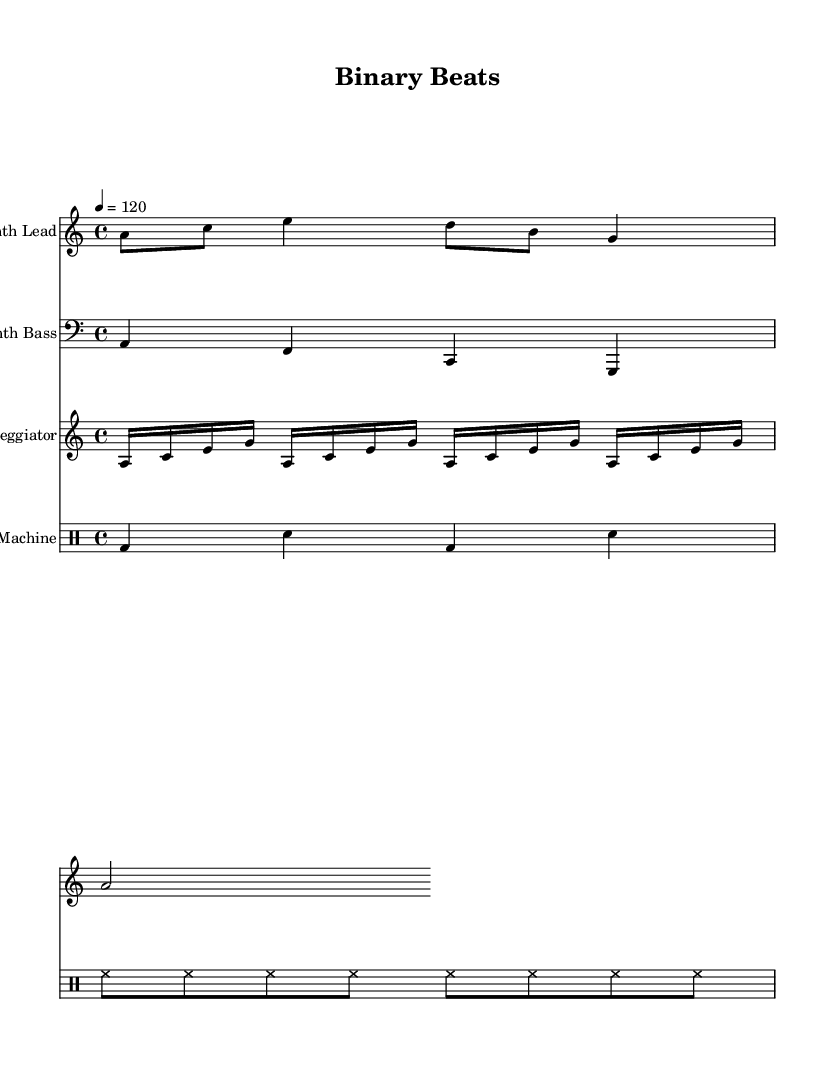What is the key signature of this music? The key signature is A minor, which has no sharps or flats.
Answer: A minor What is the time signature of the piece? The time signature is indicated as 4/4, which means there are four beats per measure and the quarter note gets one beat.
Answer: 4/4 What is the tempo marking given for this piece? The tempo marking is 120, which indicates the speed at which the piece should be played, specifically 120 beats per minute.
Answer: 120 How many measures are present in the Synth Lead part? The Synth Lead part has a total of 8 eighth notes, which cover 4 measures based on the 4/4 time signature.
Answer: 4 What type of percussion instrument is notated in the drum pattern? The drum pattern notates a bass drum and a snare drum, which are common percussion instruments in electronic music.
Answer: Bass drum, snare drum What rhythmic value does the arpeggiator section start with? The arpeggiator section starts with sixteenth notes, which are frequently used in synthwave to build a rhythmic foundation.
Answer: Sixteenth notes What instrument is represented by the clef in the Synth Bass part? The clef used in the Synth Bass part is the bass clef, indicating that this instrument plays lower register notes.
Answer: Bass clef 